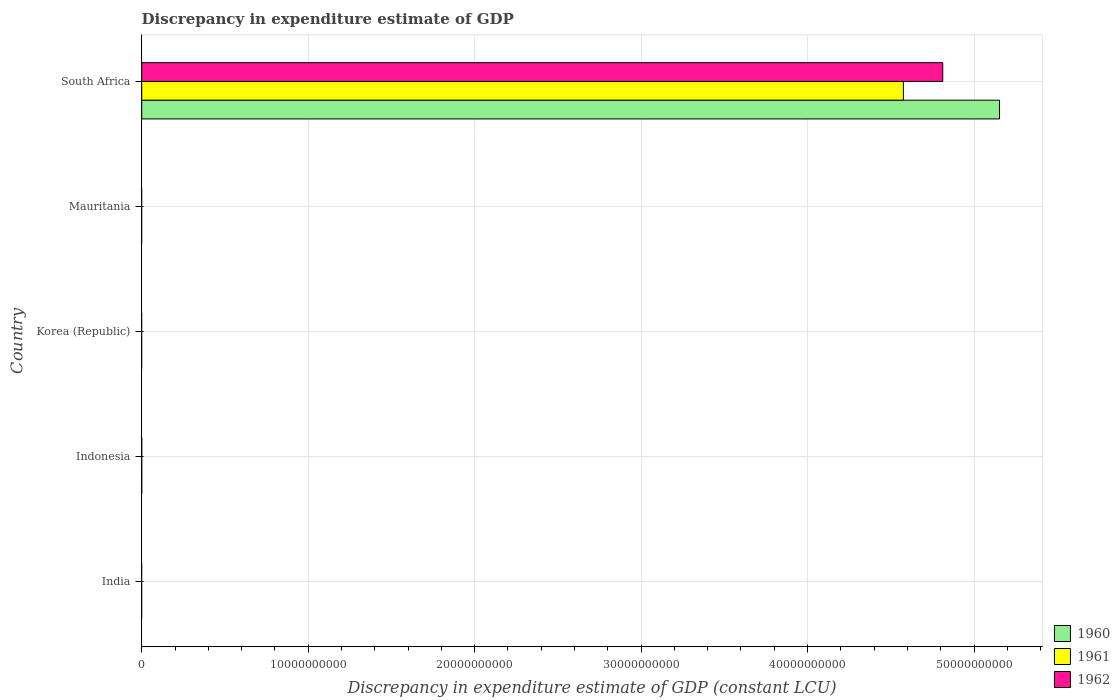How many different coloured bars are there?
Provide a short and direct response. 3. Are the number of bars on each tick of the Y-axis equal?
Ensure brevity in your answer.  No. How many bars are there on the 3rd tick from the top?
Offer a terse response. 0. What is the label of the 2nd group of bars from the top?
Provide a short and direct response. Mauritania. What is the discrepancy in expenditure estimate of GDP in 1961 in Indonesia?
Provide a short and direct response. 0. Across all countries, what is the maximum discrepancy in expenditure estimate of GDP in 1960?
Your response must be concise. 5.15e+1. In which country was the discrepancy in expenditure estimate of GDP in 1960 maximum?
Make the answer very short. South Africa. What is the total discrepancy in expenditure estimate of GDP in 1961 in the graph?
Your answer should be compact. 4.58e+1. What is the average discrepancy in expenditure estimate of GDP in 1962 per country?
Provide a succinct answer. 9.62e+09. What is the difference between the discrepancy in expenditure estimate of GDP in 1962 and discrepancy in expenditure estimate of GDP in 1960 in South Africa?
Give a very brief answer. -3.41e+09. In how many countries, is the discrepancy in expenditure estimate of GDP in 1961 greater than 18000000000 LCU?
Make the answer very short. 1. What is the difference between the highest and the lowest discrepancy in expenditure estimate of GDP in 1961?
Give a very brief answer. 4.58e+1. Are all the bars in the graph horizontal?
Your answer should be compact. Yes. What is the difference between two consecutive major ticks on the X-axis?
Provide a succinct answer. 1.00e+1. Does the graph contain grids?
Offer a very short reply. Yes. Where does the legend appear in the graph?
Offer a very short reply. Bottom right. What is the title of the graph?
Keep it short and to the point. Discrepancy in expenditure estimate of GDP. Does "1987" appear as one of the legend labels in the graph?
Offer a terse response. No. What is the label or title of the X-axis?
Provide a succinct answer. Discrepancy in expenditure estimate of GDP (constant LCU). What is the Discrepancy in expenditure estimate of GDP (constant LCU) of 1960 in India?
Your answer should be very brief. 0. What is the Discrepancy in expenditure estimate of GDP (constant LCU) in 1961 in India?
Ensure brevity in your answer.  0. What is the Discrepancy in expenditure estimate of GDP (constant LCU) in 1962 in India?
Your answer should be compact. 0. What is the Discrepancy in expenditure estimate of GDP (constant LCU) of 1960 in Indonesia?
Keep it short and to the point. 0. What is the Discrepancy in expenditure estimate of GDP (constant LCU) in 1961 in Indonesia?
Ensure brevity in your answer.  0. What is the Discrepancy in expenditure estimate of GDP (constant LCU) of 1960 in Korea (Republic)?
Make the answer very short. 0. What is the Discrepancy in expenditure estimate of GDP (constant LCU) in 1961 in Korea (Republic)?
Offer a terse response. 0. What is the Discrepancy in expenditure estimate of GDP (constant LCU) in 1962 in Mauritania?
Provide a succinct answer. 0. What is the Discrepancy in expenditure estimate of GDP (constant LCU) in 1960 in South Africa?
Your answer should be compact. 5.15e+1. What is the Discrepancy in expenditure estimate of GDP (constant LCU) of 1961 in South Africa?
Ensure brevity in your answer.  4.58e+1. What is the Discrepancy in expenditure estimate of GDP (constant LCU) of 1962 in South Africa?
Ensure brevity in your answer.  4.81e+1. Across all countries, what is the maximum Discrepancy in expenditure estimate of GDP (constant LCU) of 1960?
Give a very brief answer. 5.15e+1. Across all countries, what is the maximum Discrepancy in expenditure estimate of GDP (constant LCU) of 1961?
Provide a succinct answer. 4.58e+1. Across all countries, what is the maximum Discrepancy in expenditure estimate of GDP (constant LCU) in 1962?
Your answer should be compact. 4.81e+1. Across all countries, what is the minimum Discrepancy in expenditure estimate of GDP (constant LCU) of 1962?
Provide a short and direct response. 0. What is the total Discrepancy in expenditure estimate of GDP (constant LCU) of 1960 in the graph?
Provide a short and direct response. 5.15e+1. What is the total Discrepancy in expenditure estimate of GDP (constant LCU) in 1961 in the graph?
Provide a succinct answer. 4.58e+1. What is the total Discrepancy in expenditure estimate of GDP (constant LCU) in 1962 in the graph?
Provide a short and direct response. 4.81e+1. What is the average Discrepancy in expenditure estimate of GDP (constant LCU) in 1960 per country?
Ensure brevity in your answer.  1.03e+1. What is the average Discrepancy in expenditure estimate of GDP (constant LCU) of 1961 per country?
Keep it short and to the point. 9.15e+09. What is the average Discrepancy in expenditure estimate of GDP (constant LCU) in 1962 per country?
Your answer should be compact. 9.62e+09. What is the difference between the Discrepancy in expenditure estimate of GDP (constant LCU) of 1960 and Discrepancy in expenditure estimate of GDP (constant LCU) of 1961 in South Africa?
Ensure brevity in your answer.  5.78e+09. What is the difference between the Discrepancy in expenditure estimate of GDP (constant LCU) of 1960 and Discrepancy in expenditure estimate of GDP (constant LCU) of 1962 in South Africa?
Offer a terse response. 3.41e+09. What is the difference between the Discrepancy in expenditure estimate of GDP (constant LCU) in 1961 and Discrepancy in expenditure estimate of GDP (constant LCU) in 1962 in South Africa?
Your answer should be very brief. -2.37e+09. What is the difference between the highest and the lowest Discrepancy in expenditure estimate of GDP (constant LCU) in 1960?
Keep it short and to the point. 5.15e+1. What is the difference between the highest and the lowest Discrepancy in expenditure estimate of GDP (constant LCU) in 1961?
Your response must be concise. 4.58e+1. What is the difference between the highest and the lowest Discrepancy in expenditure estimate of GDP (constant LCU) of 1962?
Provide a short and direct response. 4.81e+1. 